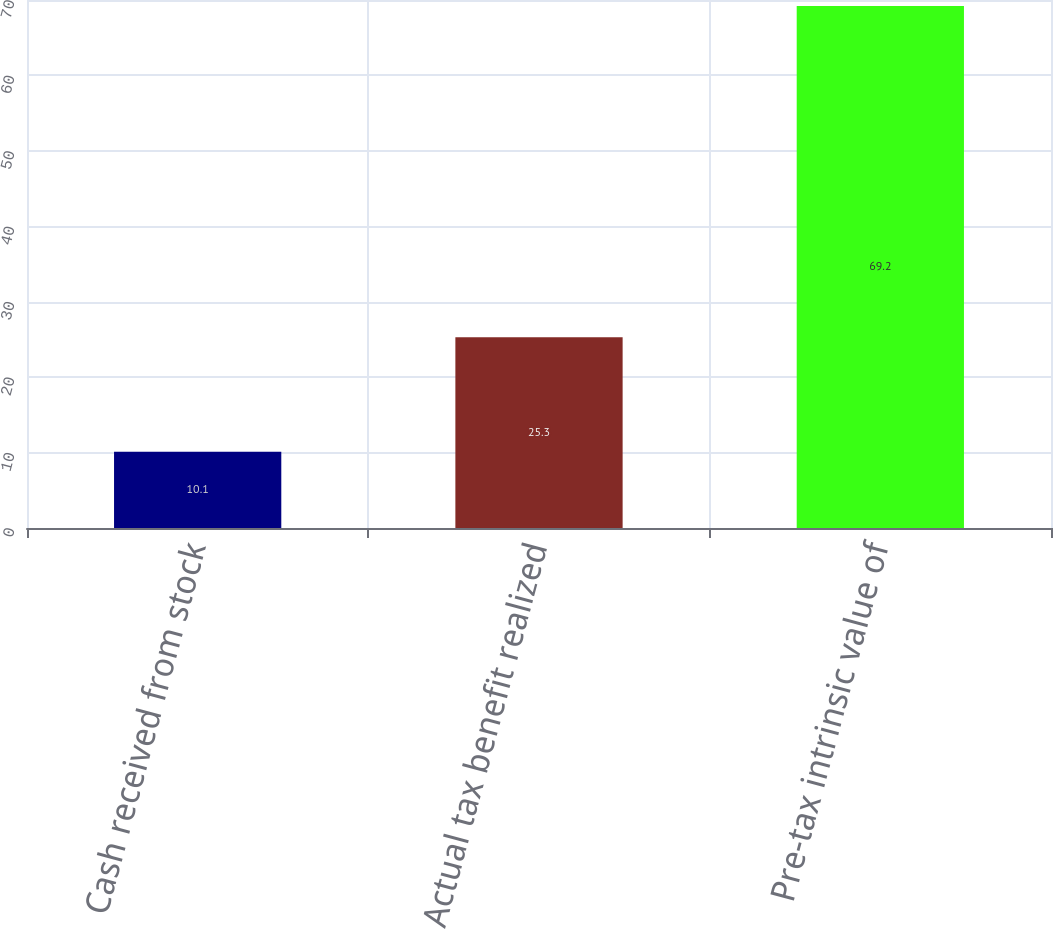Convert chart to OTSL. <chart><loc_0><loc_0><loc_500><loc_500><bar_chart><fcel>Cash received from stock<fcel>Actual tax benefit realized<fcel>Pre-tax intrinsic value of<nl><fcel>10.1<fcel>25.3<fcel>69.2<nl></chart> 